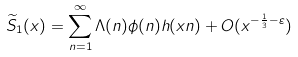Convert formula to latex. <formula><loc_0><loc_0><loc_500><loc_500>\widetilde { S } _ { 1 } ( x ) = \sum _ { n = 1 } ^ { \infty } \Lambda ( n ) \phi ( n ) h ( x n ) + O ( x ^ { - \frac { 1 } { 3 } - \varepsilon } )</formula> 